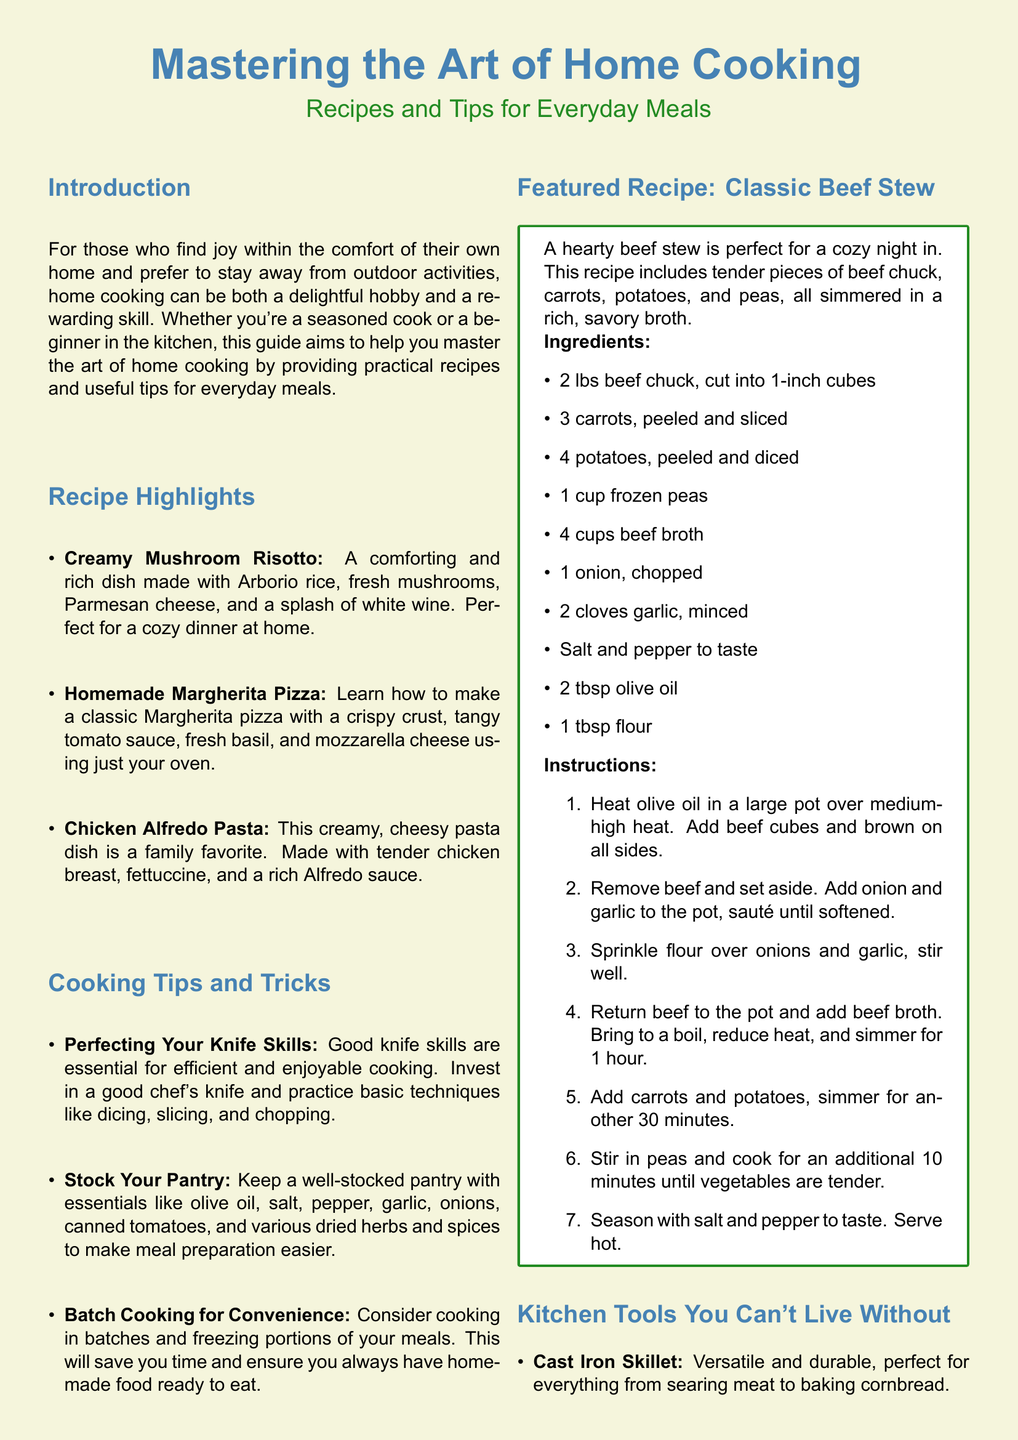What is the title of the magazine? The title is prominently displayed at the top of the document in a large font.
Answer: Mastering the Art of Home Cooking How many recipes are highlighted in the document? The highlighted recipes are listed in the Recipe Highlights section.
Answer: Three What is the featured recipe in the document? The highlighted featured recipe is expressed clearly in its own section.
Answer: Classic Beef Stew Which kitchen tool is described as versatile and durable? The document specifies a type of kitchen tool that aligns with this description.
Answer: Cast Iron Skillet What is a suggested cooking method to save time mentioned in the tips? The tips section contains practical suggestions for efficient cooking.
Answer: Batch Cooking What is the main ingredient in the Creamy Mushroom Risotto? The recipe highlights specify the main component for this dish.
Answer: Arborio rice What type of dish is Chicken Alfredo Pasta? The document categorizes this dish within the context of family-friendly meals.
Answer: Pasta What is the color of the page background? The visual aspect of the document includes a specific color for the page background.
Answer: Beige 